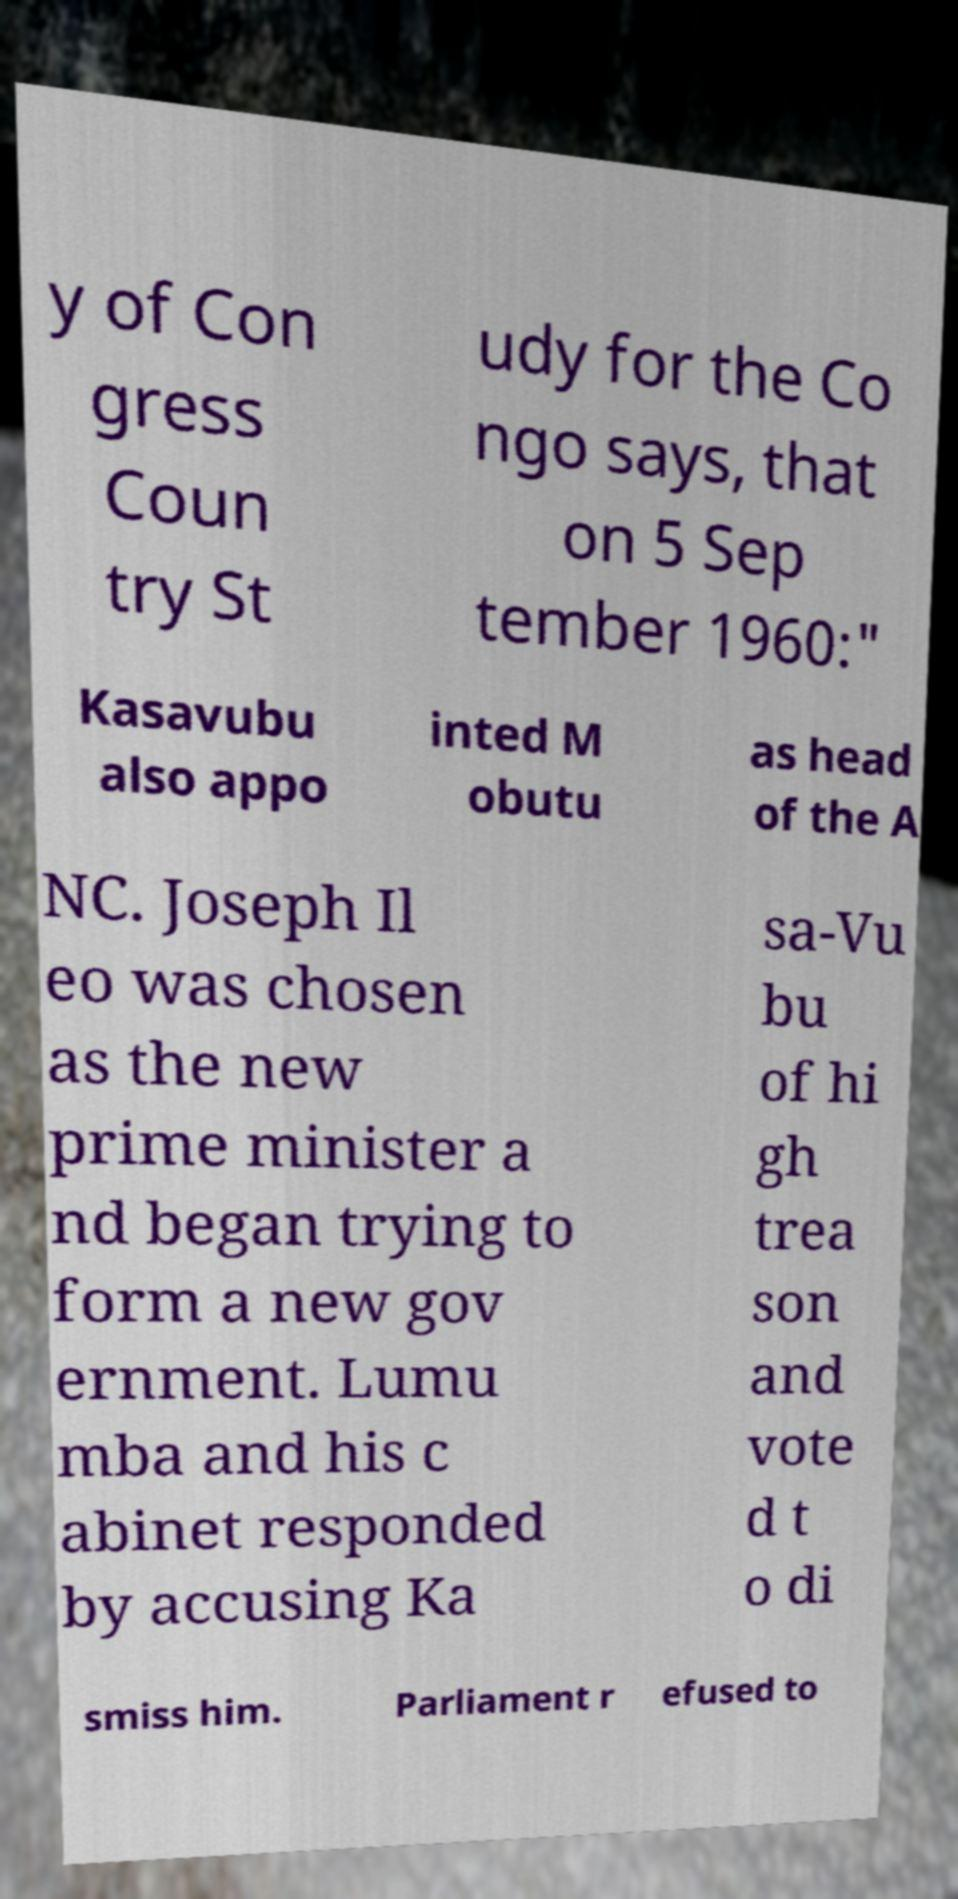Can you read and provide the text displayed in the image?This photo seems to have some interesting text. Can you extract and type it out for me? y of Con gress Coun try St udy for the Co ngo says, that on 5 Sep tember 1960:" Kasavubu also appo inted M obutu as head of the A NC. Joseph Il eo was chosen as the new prime minister a nd began trying to form a new gov ernment. Lumu mba and his c abinet responded by accusing Ka sa-Vu bu of hi gh trea son and vote d t o di smiss him. Parliament r efused to 